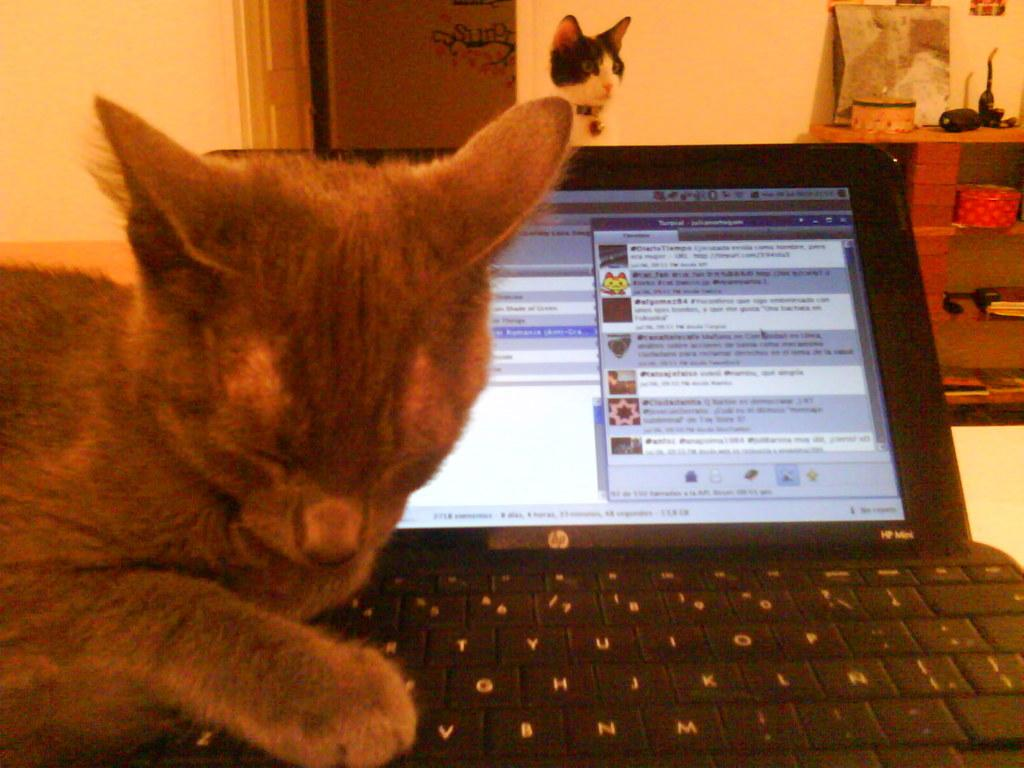What is the cat doing in the image? There is a cat on a laptop in the image. Can you describe the background of the image? There is another cat in the background of the image, along with objects in racks, a wall, and a door. What type of vacation is the cat planning on the laptop? There is no indication in the image that the cat is planning a vacation or using the laptop for that purpose. 